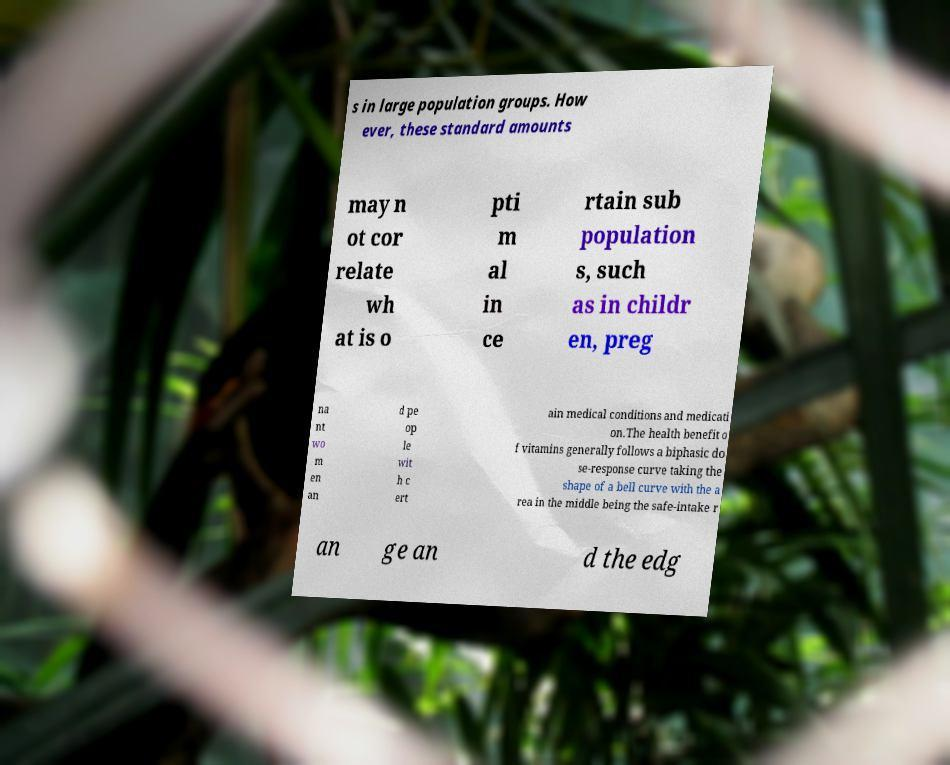Please read and relay the text visible in this image. What does it say? s in large population groups. How ever, these standard amounts may n ot cor relate wh at is o pti m al in ce rtain sub population s, such as in childr en, preg na nt wo m en an d pe op le wit h c ert ain medical conditions and medicati on.The health benefit o f vitamins generally follows a biphasic do se-response curve taking the shape of a bell curve with the a rea in the middle being the safe-intake r an ge an d the edg 